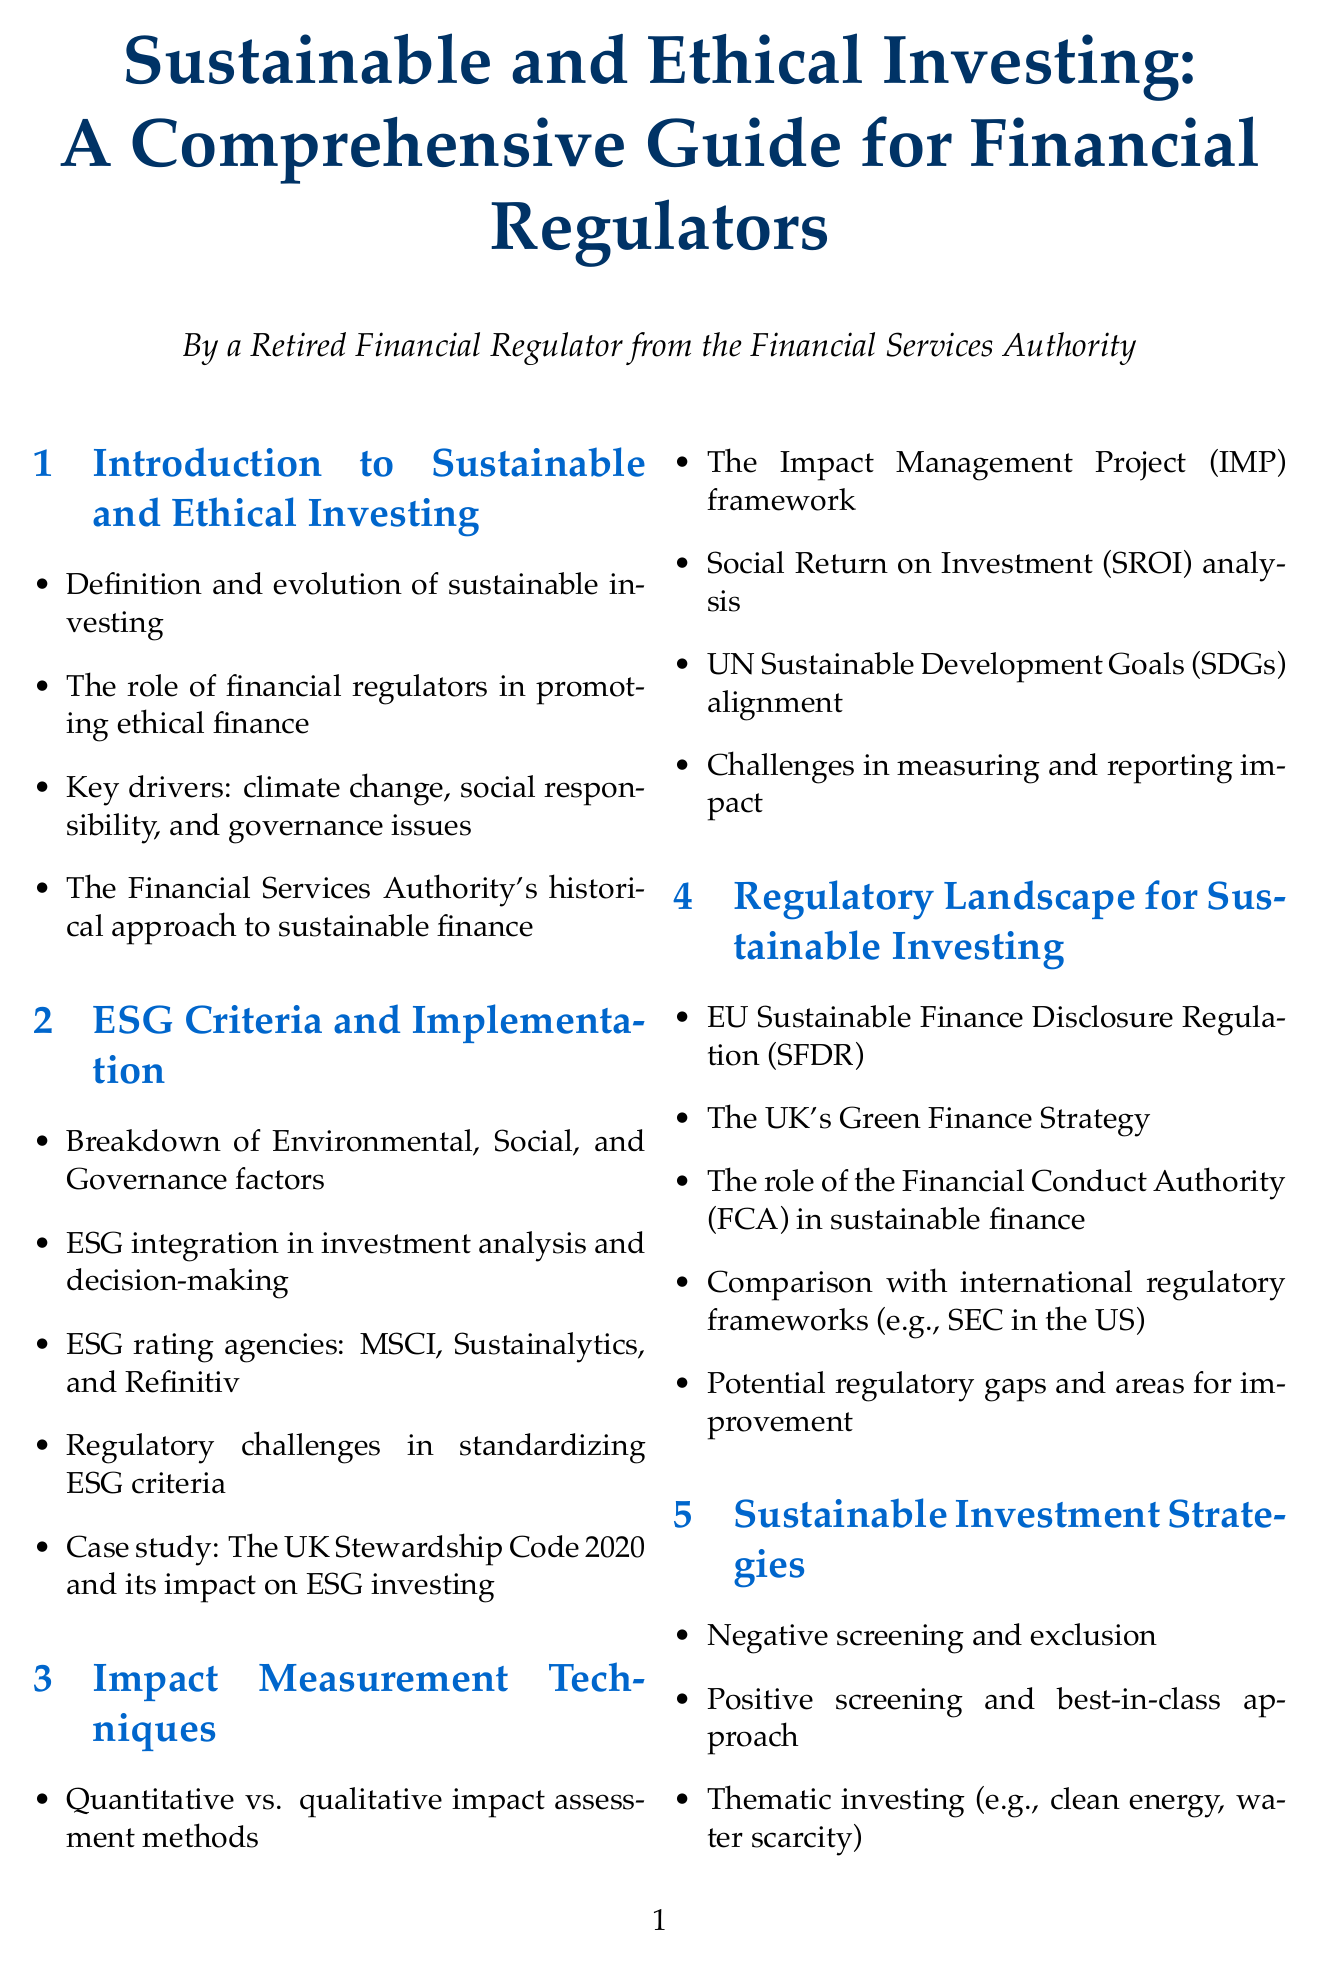What is the primary focus of the document? The document is a comprehensive guide addressing sustainable and ethical investing principles, aimed at financial regulators.
Answer: Sustainable and ethical investing Who authored the document? The author of the document is indicated as a retired financial regulator from the Financial Services Authority.
Answer: A retired financial regulator from the Financial Services Authority What are the three main factors in ESG criteria? The ESG criteria are categorized into three main factors which include Environmental, Social, and Governance.
Answer: Environmental, Social, and Governance Which regulatory framework is mentioned as a comparison for the UK? The document mentions the SEC in the US as a regulatory framework for comparison to the UK's approach.
Answer: SEC in the US What is one technique for measuring impact mentioned in the document? The document lists Social Return on Investment (SROI) analysis as one of the techniques for impact measurement.
Answer: Social Return on Investment (SROI) analysis What year is associated with the UK Stewardship Code? The UK Stewardship Code mentioned in the document is associated with the year 2020.
Answer: 2020 Which strategy is used for negative screening in sustainable investing? The document indicates that negative screening refers to excluding certain investments based on specific criteria.
Answer: Negative screening and exclusion What is a major challenge identified in sustainable investing practices? One significant challenge mentioned in the document is the risk of greenwashing, which affects the credibility of sustainable investing.
Answer: Greenwashing How does the document suggest regulators can enhance their capabilities? The document recommends enhancing supervisory capabilities specifically in sustainable finance as an approach for regulators.
Answer: Enhancing supervisory capabilities in sustainable finance 